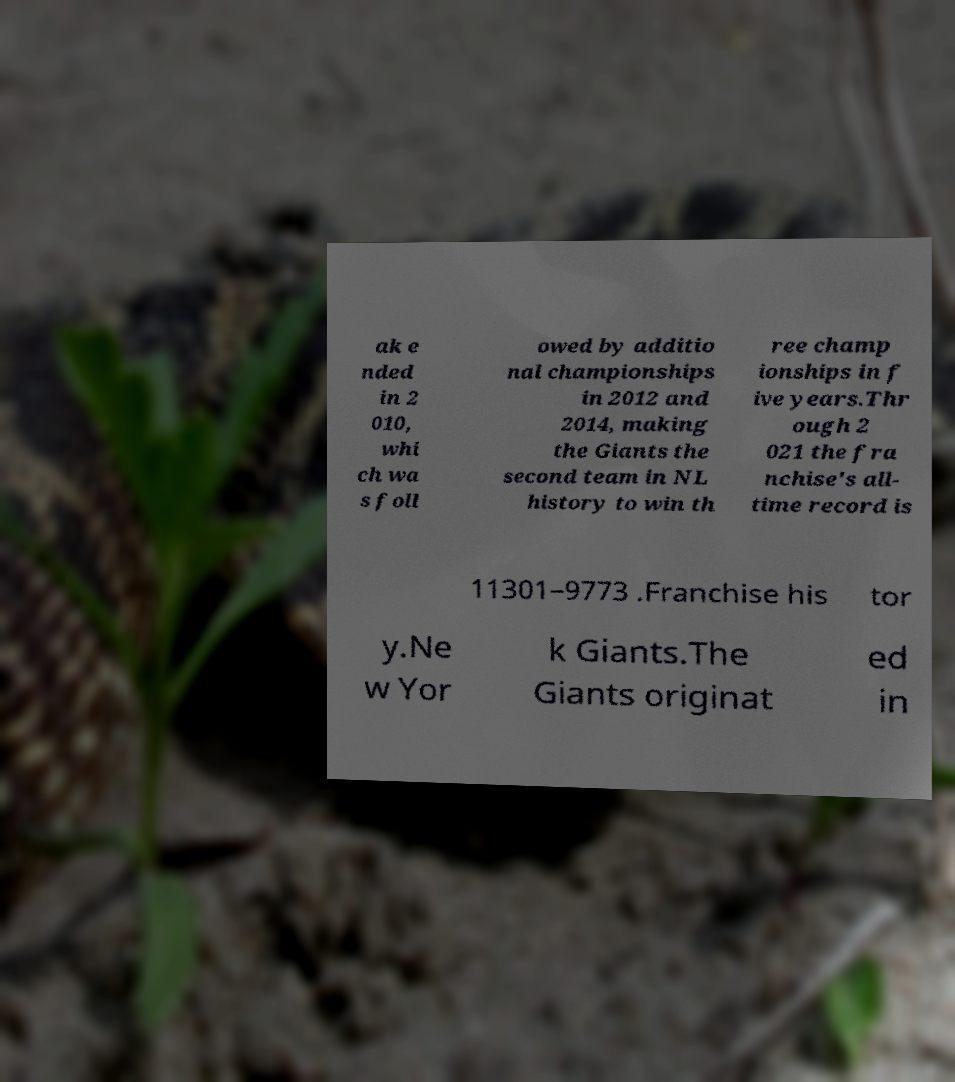Could you extract and type out the text from this image? ak e nded in 2 010, whi ch wa s foll owed by additio nal championships in 2012 and 2014, making the Giants the second team in NL history to win th ree champ ionships in f ive years.Thr ough 2 021 the fra nchise's all- time record is 11301–9773 .Franchise his tor y.Ne w Yor k Giants.The Giants originat ed in 